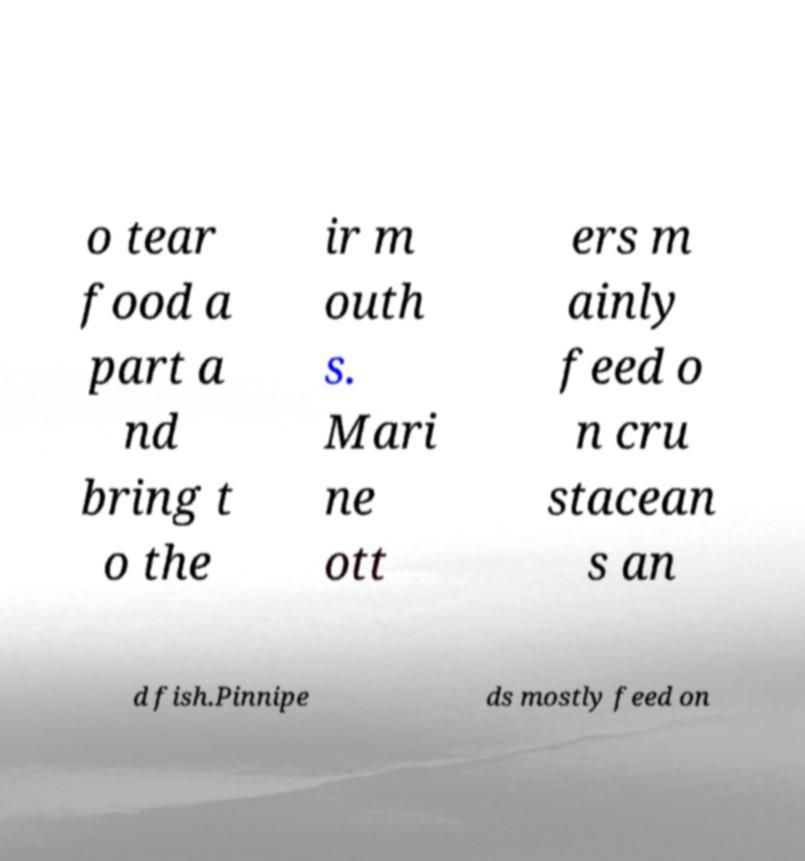Can you accurately transcribe the text from the provided image for me? o tear food a part a nd bring t o the ir m outh s. Mari ne ott ers m ainly feed o n cru stacean s an d fish.Pinnipe ds mostly feed on 